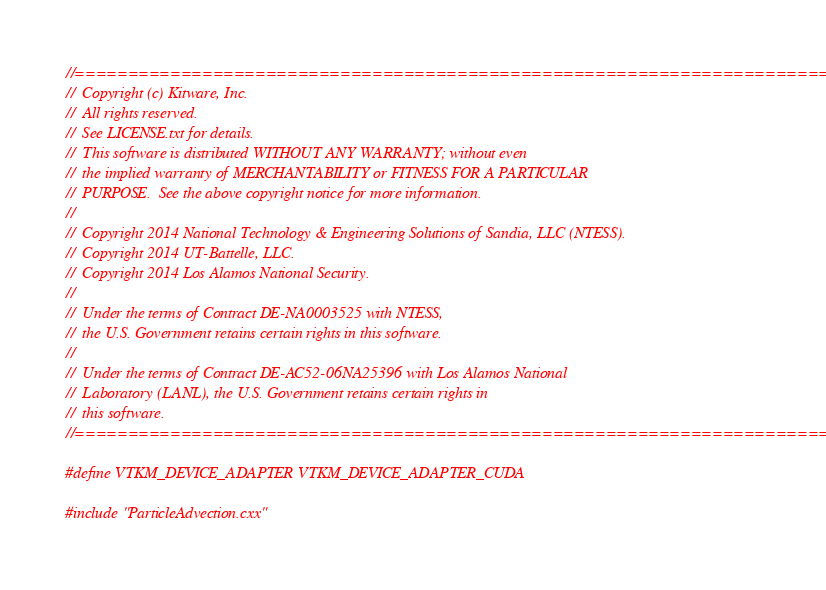<code> <loc_0><loc_0><loc_500><loc_500><_Cuda_>//============================================================================
//  Copyright (c) Kitware, Inc.
//  All rights reserved.
//  See LICENSE.txt for details.
//  This software is distributed WITHOUT ANY WARRANTY; without even
//  the implied warranty of MERCHANTABILITY or FITNESS FOR A PARTICULAR
//  PURPOSE.  See the above copyright notice for more information.
//
//  Copyright 2014 National Technology & Engineering Solutions of Sandia, LLC (NTESS).
//  Copyright 2014 UT-Battelle, LLC.
//  Copyright 2014 Los Alamos National Security.
//
//  Under the terms of Contract DE-NA0003525 with NTESS,
//  the U.S. Government retains certain rights in this software.
//
//  Under the terms of Contract DE-AC52-06NA25396 with Los Alamos National
//  Laboratory (LANL), the U.S. Government retains certain rights in
//  this software.
//============================================================================

#define VTKM_DEVICE_ADAPTER VTKM_DEVICE_ADAPTER_CUDA

#include "ParticleAdvection.cxx"
</code> 